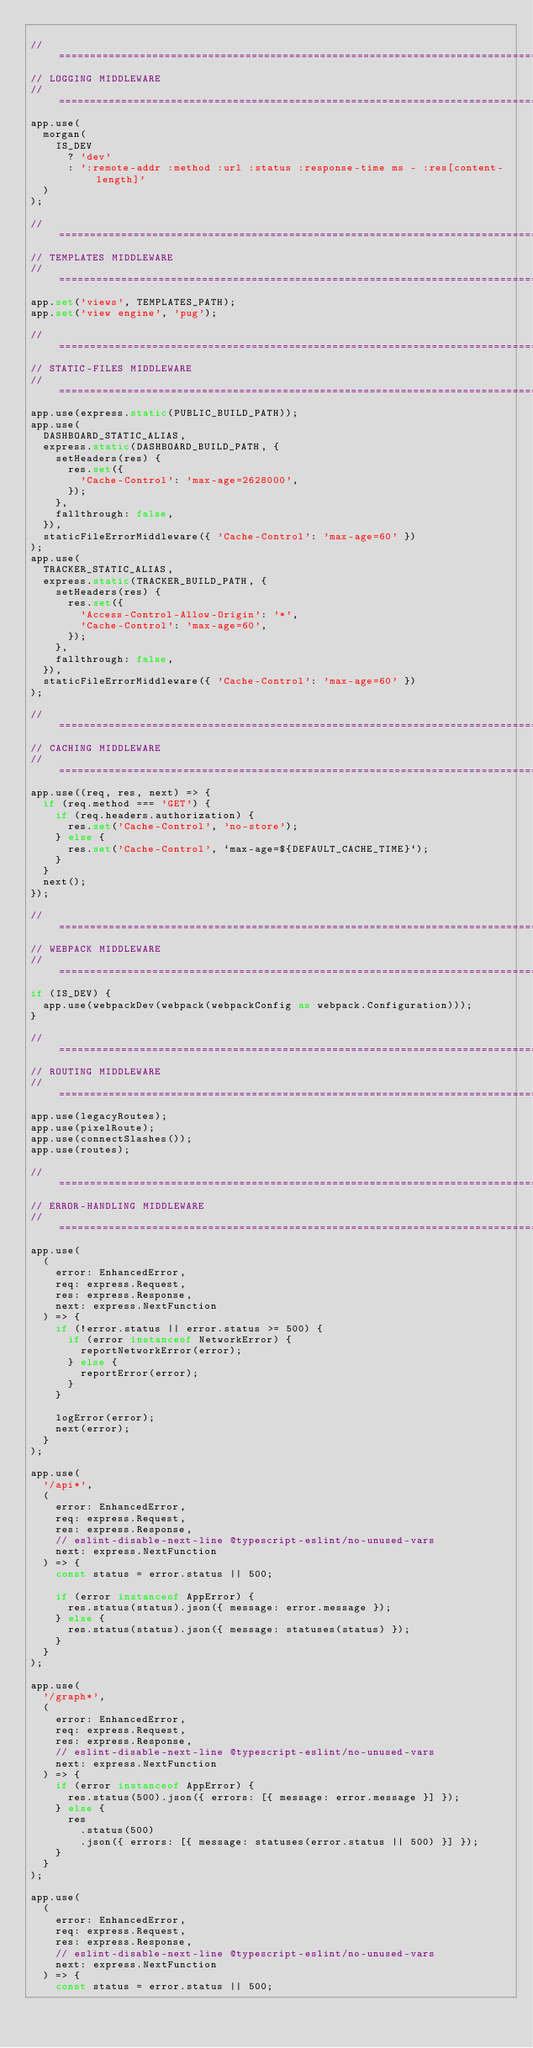<code> <loc_0><loc_0><loc_500><loc_500><_TypeScript_>
// ==============================================================================
// LOGGING MIDDLEWARE
// ==============================================================================
app.use(
  morgan(
    IS_DEV
      ? 'dev'
      : ':remote-addr :method :url :status :response-time ms - :res[content-length]'
  )
);

// ==============================================================================
// TEMPLATES MIDDLEWARE
// ==============================================================================
app.set('views', TEMPLATES_PATH);
app.set('view engine', 'pug');

// ==============================================================================
// STATIC-FILES MIDDLEWARE
// ==============================================================================
app.use(express.static(PUBLIC_BUILD_PATH));
app.use(
  DASHBOARD_STATIC_ALIAS,
  express.static(DASHBOARD_BUILD_PATH, {
    setHeaders(res) {
      res.set({
        'Cache-Control': 'max-age=2628000',
      });
    },
    fallthrough: false,
  }),
  staticFileErrorMiddleware({ 'Cache-Control': 'max-age=60' })
);
app.use(
  TRACKER_STATIC_ALIAS,
  express.static(TRACKER_BUILD_PATH, {
    setHeaders(res) {
      res.set({
        'Access-Control-Allow-Origin': '*',
        'Cache-Control': 'max-age=60',
      });
    },
    fallthrough: false,
  }),
  staticFileErrorMiddleware({ 'Cache-Control': 'max-age=60' })
);

// ==============================================================================
// CACHING MIDDLEWARE
// ==============================================================================
app.use((req, res, next) => {
  if (req.method === 'GET') {
    if (req.headers.authorization) {
      res.set('Cache-Control', 'no-store');
    } else {
      res.set('Cache-Control', `max-age=${DEFAULT_CACHE_TIME}`);
    }
  }
  next();
});

// ==============================================================================
// WEBPACK MIDDLEWARE
// ==============================================================================
if (IS_DEV) {
  app.use(webpackDev(webpack(webpackConfig as webpack.Configuration)));
}

// ==============================================================================
// ROUTING MIDDLEWARE
// ==============================================================================
app.use(legacyRoutes);
app.use(pixelRoute);
app.use(connectSlashes());
app.use(routes);

// ==============================================================================
// ERROR-HANDLING MIDDLEWARE
// ==============================================================================
app.use(
  (
    error: EnhancedError,
    req: express.Request,
    res: express.Response,
    next: express.NextFunction
  ) => {
    if (!error.status || error.status >= 500) {
      if (error instanceof NetworkError) {
        reportNetworkError(error);
      } else {
        reportError(error);
      }
    }

    logError(error);
    next(error);
  }
);

app.use(
  '/api*',
  (
    error: EnhancedError,
    req: express.Request,
    res: express.Response,
    // eslint-disable-next-line @typescript-eslint/no-unused-vars
    next: express.NextFunction
  ) => {
    const status = error.status || 500;

    if (error instanceof AppError) {
      res.status(status).json({ message: error.message });
    } else {
      res.status(status).json({ message: statuses(status) });
    }
  }
);

app.use(
  '/graph*',
  (
    error: EnhancedError,
    req: express.Request,
    res: express.Response,
    // eslint-disable-next-line @typescript-eslint/no-unused-vars
    next: express.NextFunction
  ) => {
    if (error instanceof AppError) {
      res.status(500).json({ errors: [{ message: error.message }] });
    } else {
      res
        .status(500)
        .json({ errors: [{ message: statuses(error.status || 500) }] });
    }
  }
);

app.use(
  (
    error: EnhancedError,
    req: express.Request,
    res: express.Response,
    // eslint-disable-next-line @typescript-eslint/no-unused-vars
    next: express.NextFunction
  ) => {
    const status = error.status || 500;</code> 